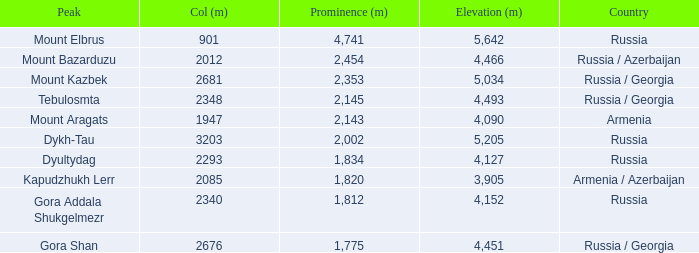What is the Elevation (m) of the Peak with a Prominence (m) larger than 2,143 and Col (m) of 2012? 4466.0. 